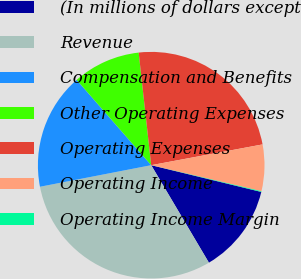<chart> <loc_0><loc_0><loc_500><loc_500><pie_chart><fcel>(In millions of dollars except<fcel>Revenue<fcel>Compensation and Benefits<fcel>Other Operating Expenses<fcel>Operating Expenses<fcel>Operating Income<fcel>Operating Income Margin<nl><fcel>12.7%<fcel>30.46%<fcel>16.62%<fcel>9.67%<fcel>23.83%<fcel>6.63%<fcel>0.1%<nl></chart> 